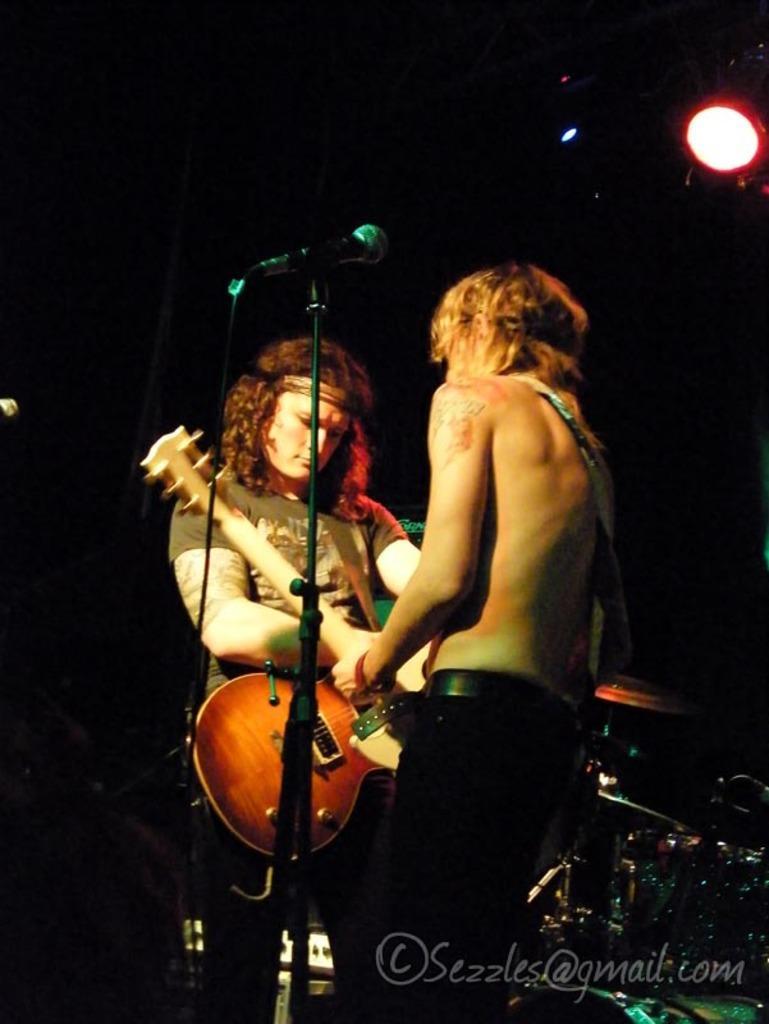Please provide a concise description of this image. In the image we can see there are people who are standing and holding guitar in their hands. 